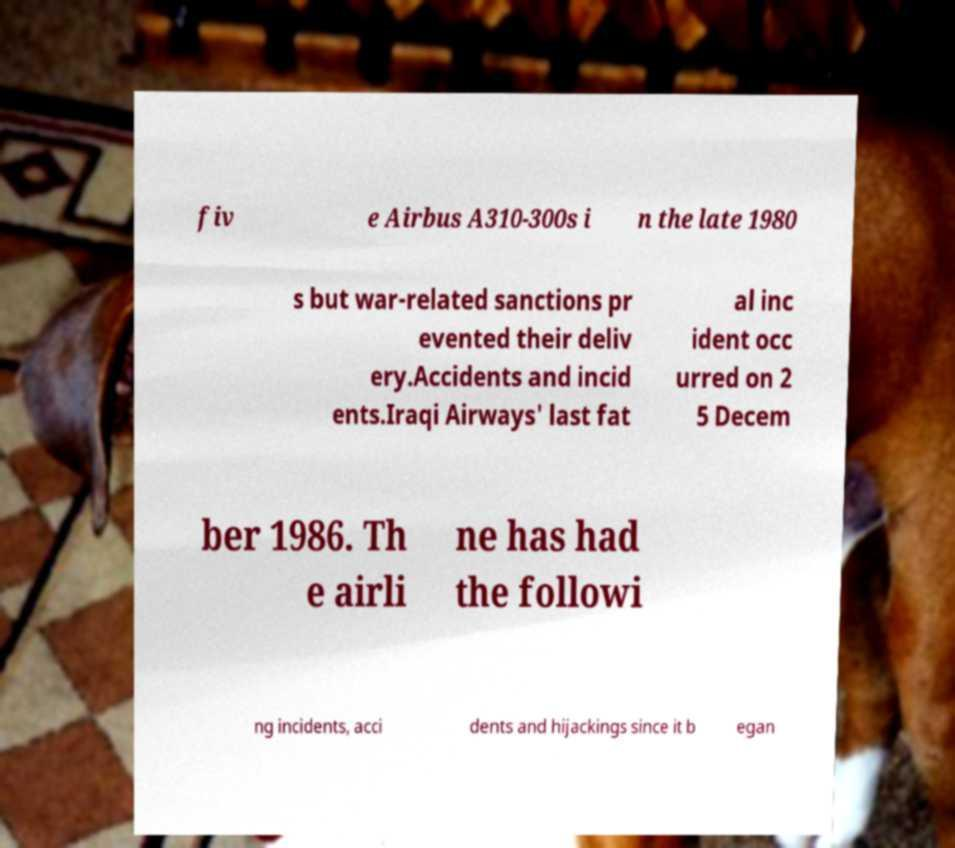Could you extract and type out the text from this image? fiv e Airbus A310-300s i n the late 1980 s but war-related sanctions pr evented their deliv ery.Accidents and incid ents.Iraqi Airways' last fat al inc ident occ urred on 2 5 Decem ber 1986. Th e airli ne has had the followi ng incidents, acci dents and hijackings since it b egan 